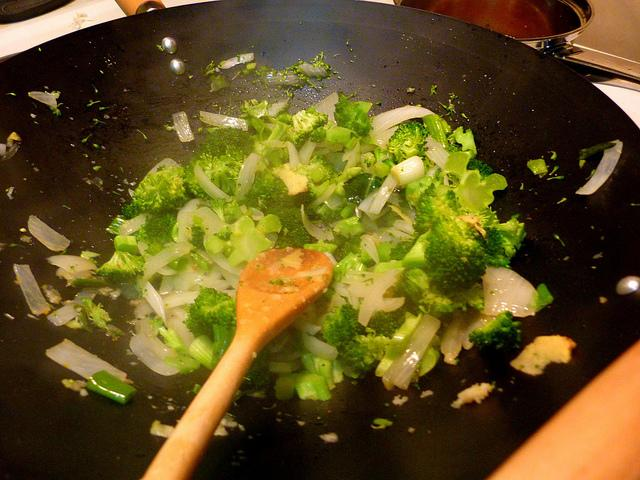What food type is in the pan? Please explain your reasoning. vegetables. There are vegetables in the pan being cooked. 